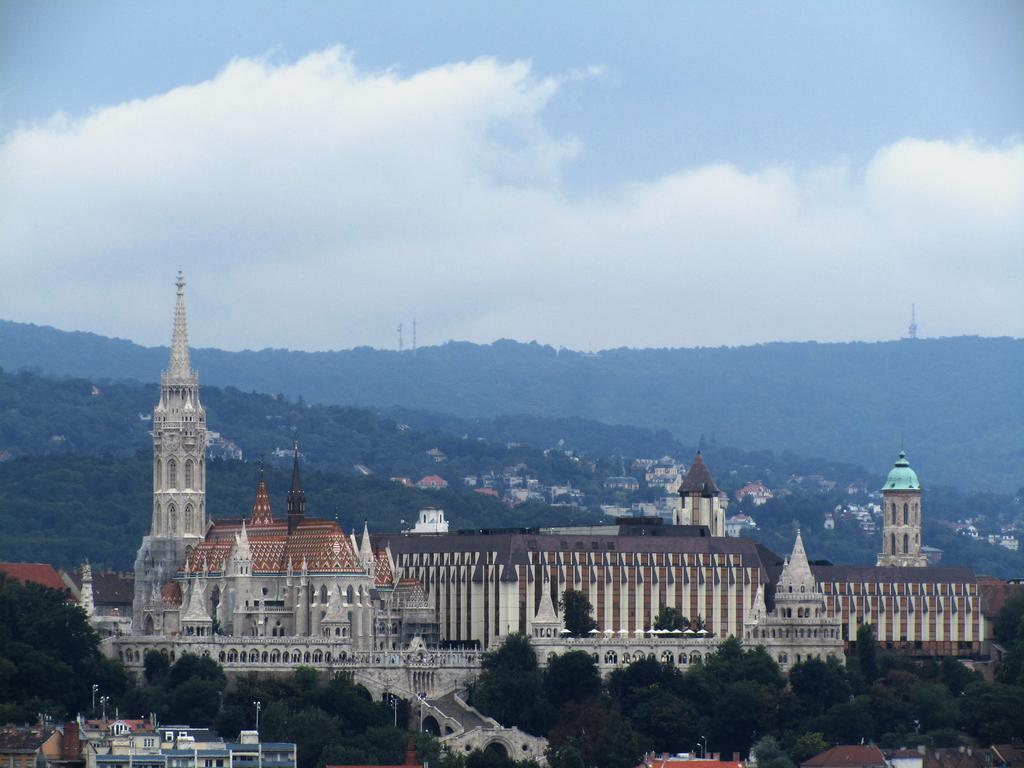Can you describe this image briefly? In this Image I can see number of buildings, number of trees, clouds and the sky in background. 